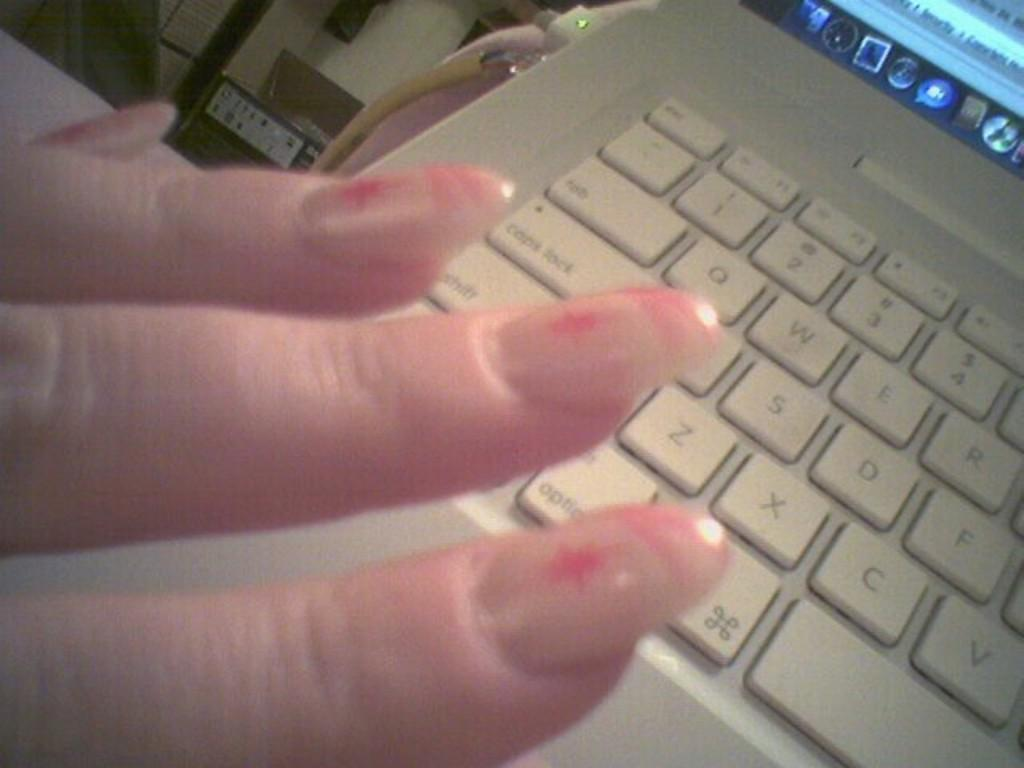<image>
Offer a succinct explanation of the picture presented. Someone holds up their nails near the z and x keys of a keyboard. 